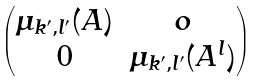<formula> <loc_0><loc_0><loc_500><loc_500>\begin{pmatrix} \mu _ { k ^ { \prime } , l ^ { \prime } } ( A ) & o \\ 0 & \mu _ { k ^ { \prime } , l ^ { \prime } } ( A ^ { l } ) \end{pmatrix}</formula> 